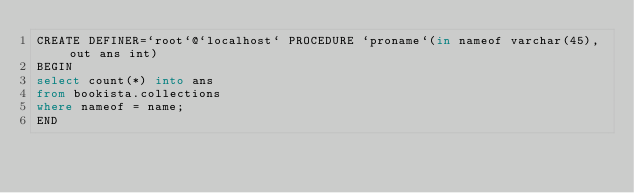<code> <loc_0><loc_0><loc_500><loc_500><_SQL_>CREATE DEFINER=`root`@`localhost` PROCEDURE `proname`(in nameof varchar(45), out ans int)
BEGIN
select count(*) into ans
from bookista.collections
where nameof = name;
END</code> 